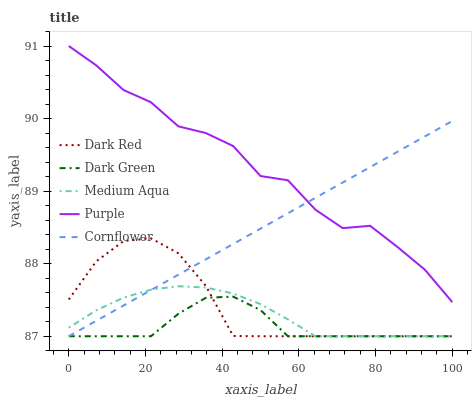Does Dark Green have the minimum area under the curve?
Answer yes or no. Yes. Does Purple have the maximum area under the curve?
Answer yes or no. Yes. Does Dark Red have the minimum area under the curve?
Answer yes or no. No. Does Dark Red have the maximum area under the curve?
Answer yes or no. No. Is Cornflower the smoothest?
Answer yes or no. Yes. Is Purple the roughest?
Answer yes or no. Yes. Is Dark Red the smoothest?
Answer yes or no. No. Is Dark Red the roughest?
Answer yes or no. No. Does Dark Red have the lowest value?
Answer yes or no. Yes. Does Purple have the highest value?
Answer yes or no. Yes. Does Dark Red have the highest value?
Answer yes or no. No. Is Dark Green less than Purple?
Answer yes or no. Yes. Is Purple greater than Dark Red?
Answer yes or no. Yes. Does Dark Red intersect Dark Green?
Answer yes or no. Yes. Is Dark Red less than Dark Green?
Answer yes or no. No. Is Dark Red greater than Dark Green?
Answer yes or no. No. Does Dark Green intersect Purple?
Answer yes or no. No. 